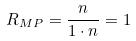Convert formula to latex. <formula><loc_0><loc_0><loc_500><loc_500>R _ { M P } = \frac { n } { 1 \cdot n } = 1</formula> 